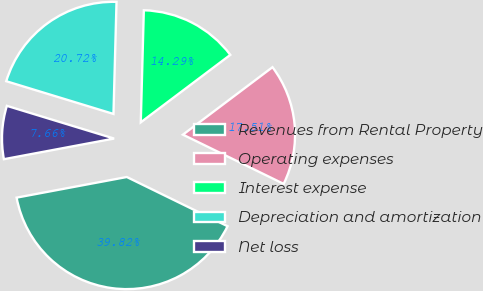Convert chart. <chart><loc_0><loc_0><loc_500><loc_500><pie_chart><fcel>Revenues from Rental Property<fcel>Operating expenses<fcel>Interest expense<fcel>Depreciation and amortization<fcel>Net loss<nl><fcel>39.82%<fcel>17.51%<fcel>14.29%<fcel>20.72%<fcel>7.66%<nl></chart> 